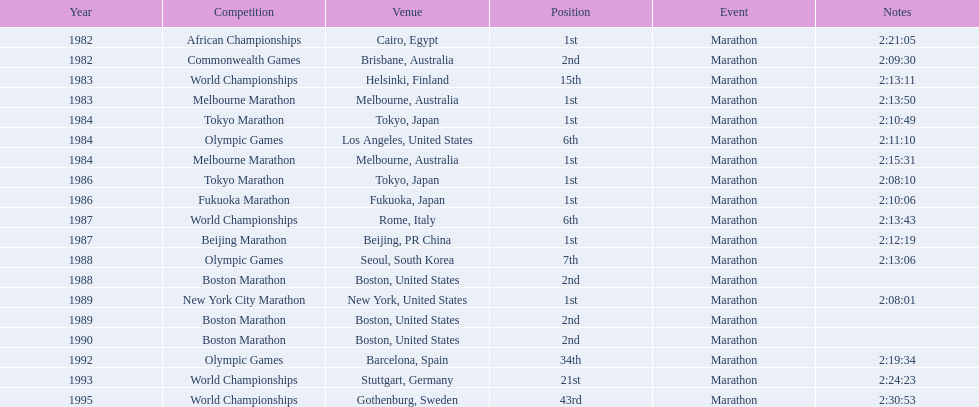What are all of the juma ikangaa competitions? African Championships, Commonwealth Games, World Championships, Melbourne Marathon, Tokyo Marathon, Olympic Games, Melbourne Marathon, Tokyo Marathon, Fukuoka Marathon, World Championships, Beijing Marathon, Olympic Games, Boston Marathon, New York City Marathon, Boston Marathon, Boston Marathon, Olympic Games, World Championships, World Championships. Which of these competitions did not take place in the united states? African Championships, Commonwealth Games, World Championships, Melbourne Marathon, Tokyo Marathon, Melbourne Marathon, Tokyo Marathon, Fukuoka Marathon, World Championships, Beijing Marathon, Olympic Games, Olympic Games, World Championships, World Championships. Out of these, which of them took place in asia? Tokyo Marathon, Tokyo Marathon, Fukuoka Marathon, Beijing Marathon, Olympic Games. Which of the remaining competitions took place in china? Beijing Marathon. What are all of the juma ikangaa contests? African Championships, Commonwealth Games, World Championships, Melbourne Marathon, Tokyo Marathon, Olympic Games, Melbourne Marathon, Tokyo Marathon, Fukuoka Marathon, World Championships, Beijing Marathon, Olympic Games, Boston Marathon, New York City Marathon, Boston Marathon, Boston Marathon, Olympic Games, World Championships, World Championships. Which of these contests did not occur in the united states? African Championships, Commonwealth Games, World Championships, Melbourne Marathon, Tokyo Marathon, Melbourne Marathon, Tokyo Marathon, Fukuoka Marathon, World Championships, Beijing Marathon, Olympic Games, Olympic Games, World Championships, World Championships. Out of these, which of them happened in asia? Tokyo Marathon, Tokyo Marathon, Fukuoka Marathon, Beijing Marathon, Olympic Games. Which of the remaining contests occurred in china? Beijing Marathon. Can you parse all the data within this table? {'header': ['Year', 'Competition', 'Venue', 'Position', 'Event', 'Notes'], 'rows': [['1982', 'African Championships', 'Cairo, Egypt', '1st', 'Marathon', '2:21:05'], ['1982', 'Commonwealth Games', 'Brisbane, Australia', '2nd', 'Marathon', '2:09:30'], ['1983', 'World Championships', 'Helsinki, Finland', '15th', 'Marathon', '2:13:11'], ['1983', 'Melbourne Marathon', 'Melbourne, Australia', '1st', 'Marathon', '2:13:50'], ['1984', 'Tokyo Marathon', 'Tokyo, Japan', '1st', 'Marathon', '2:10:49'], ['1984', 'Olympic Games', 'Los Angeles, United States', '6th', 'Marathon', '2:11:10'], ['1984', 'Melbourne Marathon', 'Melbourne, Australia', '1st', 'Marathon', '2:15:31'], ['1986', 'Tokyo Marathon', 'Tokyo, Japan', '1st', 'Marathon', '2:08:10'], ['1986', 'Fukuoka Marathon', 'Fukuoka, Japan', '1st', 'Marathon', '2:10:06'], ['1987', 'World Championships', 'Rome, Italy', '6th', 'Marathon', '2:13:43'], ['1987', 'Beijing Marathon', 'Beijing, PR China', '1st', 'Marathon', '2:12:19'], ['1988', 'Olympic Games', 'Seoul, South Korea', '7th', 'Marathon', '2:13:06'], ['1988', 'Boston Marathon', 'Boston, United States', '2nd', 'Marathon', ''], ['1989', 'New York City Marathon', 'New York, United States', '1st', 'Marathon', '2:08:01'], ['1989', 'Boston Marathon', 'Boston, United States', '2nd', 'Marathon', ''], ['1990', 'Boston Marathon', 'Boston, United States', '2nd', 'Marathon', ''], ['1992', 'Olympic Games', 'Barcelona, Spain', '34th', 'Marathon', '2:19:34'], ['1993', 'World Championships', 'Stuttgart, Germany', '21st', 'Marathon', '2:24:23'], ['1995', 'World Championships', 'Gothenburg, Sweden', '43rd', 'Marathon', '2:30:53']]} 